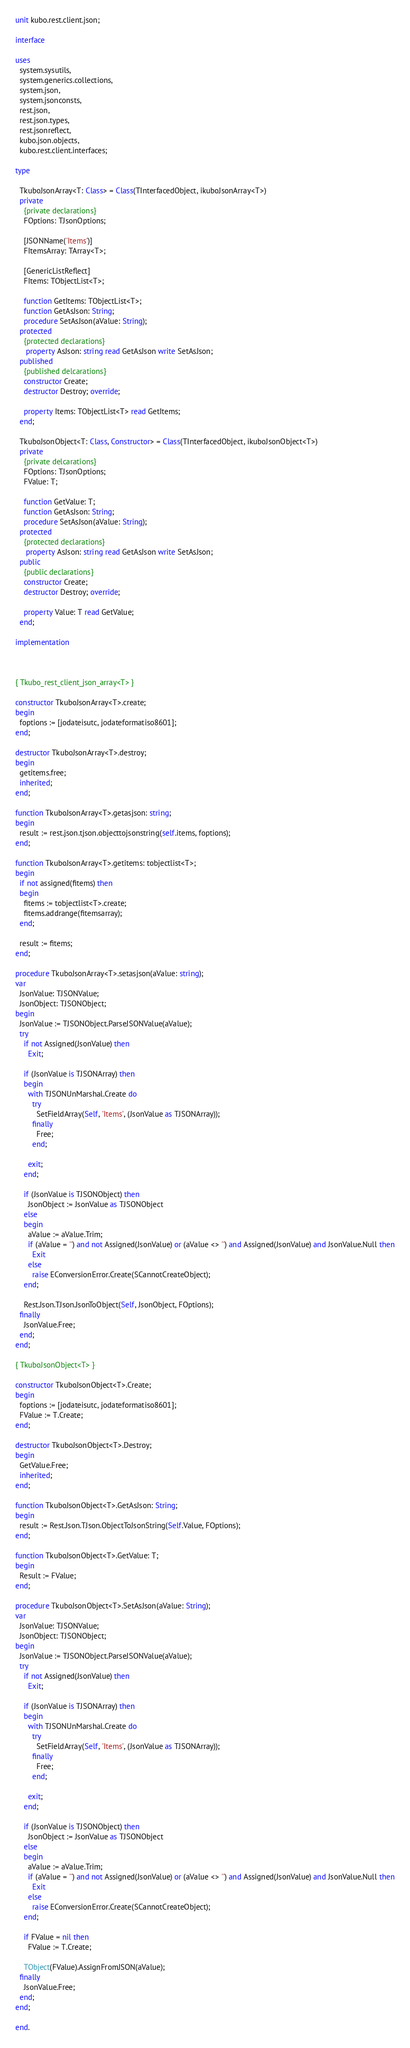<code> <loc_0><loc_0><loc_500><loc_500><_Pascal_>unit kubo.rest.client.json;

interface

uses
  system.sysutils,
  system.generics.collections,
  system.json,
  system.jsonconsts,
  rest.json,
  rest.json.types,
  rest.jsonreflect,
  kubo.json.objects,
  kubo.rest.client.interfaces;

type

  TkuboJsonArray<T: Class> = Class(TInterfacedObject, ikuboJsonArray<T>)
  private
    {private declarations}
    FOptions: TJsonOptions;

    [JSONName('Items')]
    FItemsArray: TArray<T>;

    [GenericListReflect]
    FItems: TObjectList<T>;

    function GetItems: TObjectList<T>;
    function GetAsJson: String;
    procedure SetAsJson(aValue: String);
  protected
    {protected declarations}
     property AsJson: string read GetAsJson write SetAsJson;
  published
    {published delcarations}
    constructor Create;
    destructor Destroy; override;

    property Items: TObjectList<T> read GetItems;
  end;

  TkuboJsonObject<T: Class, Constructor> = Class(TInterfacedObject, ikuboJsonObject<T>)
  private
    {private delcarations}
    FOptions: TJsonOptions;
    FValue: T;

    function GetValue: T;
    function GetAsJson: String;
    procedure SetAsJson(aValue: String);
  protected
    {protected declarations}
     property AsJson: string read GetAsJson write SetAsJson;
  public
    {public declarations}
    constructor Create;
    destructor Destroy; override;

    property Value: T read GetValue;
  end;

implementation



{ Tkubo_rest_client_json_array<T> }

constructor TkuboJsonArray<T>.create;
begin
  foptions := [jodateisutc, jodateformatiso8601];
end;

destructor TkuboJsonArray<T>.destroy;
begin
  getitems.free;
  inherited;
end;

function TkuboJsonArray<T>.getasjson: string;
begin
  result := rest.json.tjson.objecttojsonstring(self.items, foptions);
end;

function TkuboJsonArray<T>.getitems: tobjectlist<T>;
begin
  if not assigned(fitems) then
  begin
    fitems := tobjectlist<T>.create;
    fitems.addrange(fitemsarray);
  end;

  result := fitems;
end;

procedure TkuboJsonArray<T>.setasjson(aValue: string);
var
  JsonValue: TJSONValue;
  JsonObject: TJSONObject;
begin
  JsonValue := TJSONObject.ParseJSONValue(aValue);
  try
    if not Assigned(JsonValue) then
      Exit;

    if (JsonValue is TJSONArray) then
    begin
      with TJSONUnMarshal.Create do
        try
          SetFieldArray(Self, 'Items', (JsonValue as TJSONArray));
        finally
          Free;
        end;

      exit;
    end;

    if (JsonValue is TJSONObject) then
      JsonObject := JsonValue as TJSONObject
    else
    begin
      aValue := aValue.Trim;
      if (aValue = '') and not Assigned(JsonValue) or (aValue <> '') and Assigned(JsonValue) and JsonValue.Null then
        Exit
      else
        raise EConversionError.Create(SCannotCreateObject);
    end;

    Rest.Json.TJson.JsonToObject(Self, JsonObject, FOptions);
  finally
    JsonValue.Free;
  end;
end;

{ TkuboJsonObject<T> }

constructor TkuboJsonObject<T>.Create;
begin
  foptions := [jodateisutc, jodateformatiso8601];
  FValue := T.Create;
end;

destructor TkuboJsonObject<T>.Destroy;
begin
  GetValue.Free;
  inherited;
end;

function TkuboJsonObject<T>.GetAsJson: String;
begin
  result := Rest.Json.TJson.ObjectToJsonString(Self.Value, FOptions);
end;

function TkuboJsonObject<T>.GetValue: T;
begin
  Result := FValue;
end;

procedure TkuboJsonObject<T>.SetAsJson(aValue: String);
var
  JsonValue: TJSONValue;
  JsonObject: TJSONObject;
begin
  JsonValue := TJSONObject.ParseJSONValue(aValue);
  try
    if not Assigned(JsonValue) then
      Exit;

    if (JsonValue is TJSONArray) then
    begin
      with TJSONUnMarshal.Create do
        try
          SetFieldArray(Self, 'Items', (JsonValue as TJSONArray));
        finally
          Free;
        end;

      exit;
    end;

    if (JsonValue is TJSONObject) then
      JsonObject := JsonValue as TJSONObject
    else
    begin
      aValue := aValue.Trim;
      if (aValue = '') and not Assigned(JsonValue) or (aValue <> '') and Assigned(JsonValue) and JsonValue.Null then
        Exit
      else
        raise EConversionError.Create(SCannotCreateObject);
    end;

    if FValue = nil then
      FValue := T.Create;

    TObject(FValue).AssignFromJSON(aValue);
  finally
    JsonValue.Free;
  end;
end;

end.
</code> 